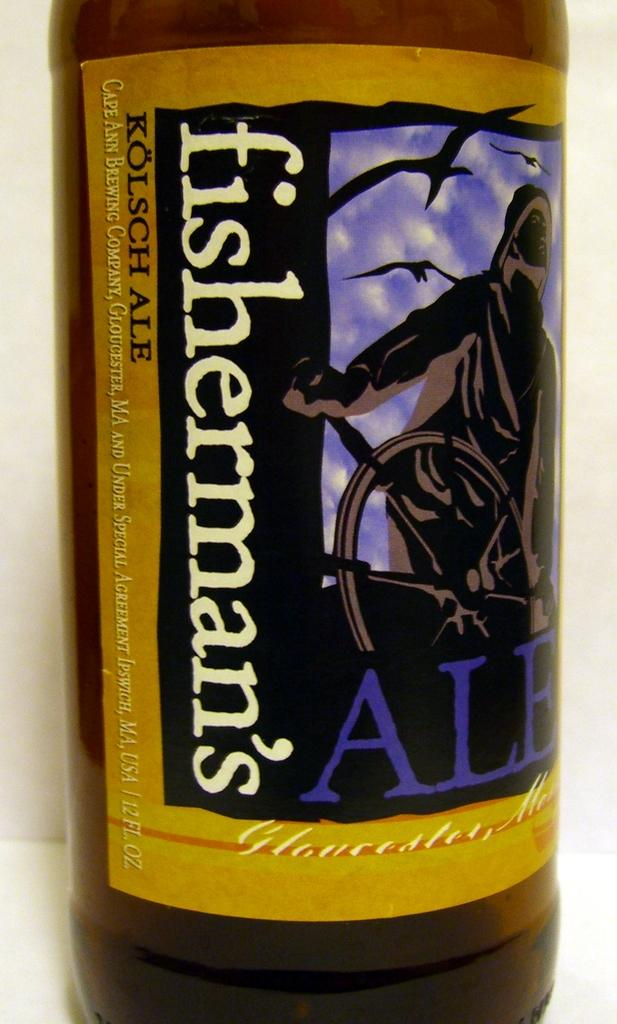<image>
Provide a brief description of the given image. A closeup of the label on a fisherman's Ale beer 